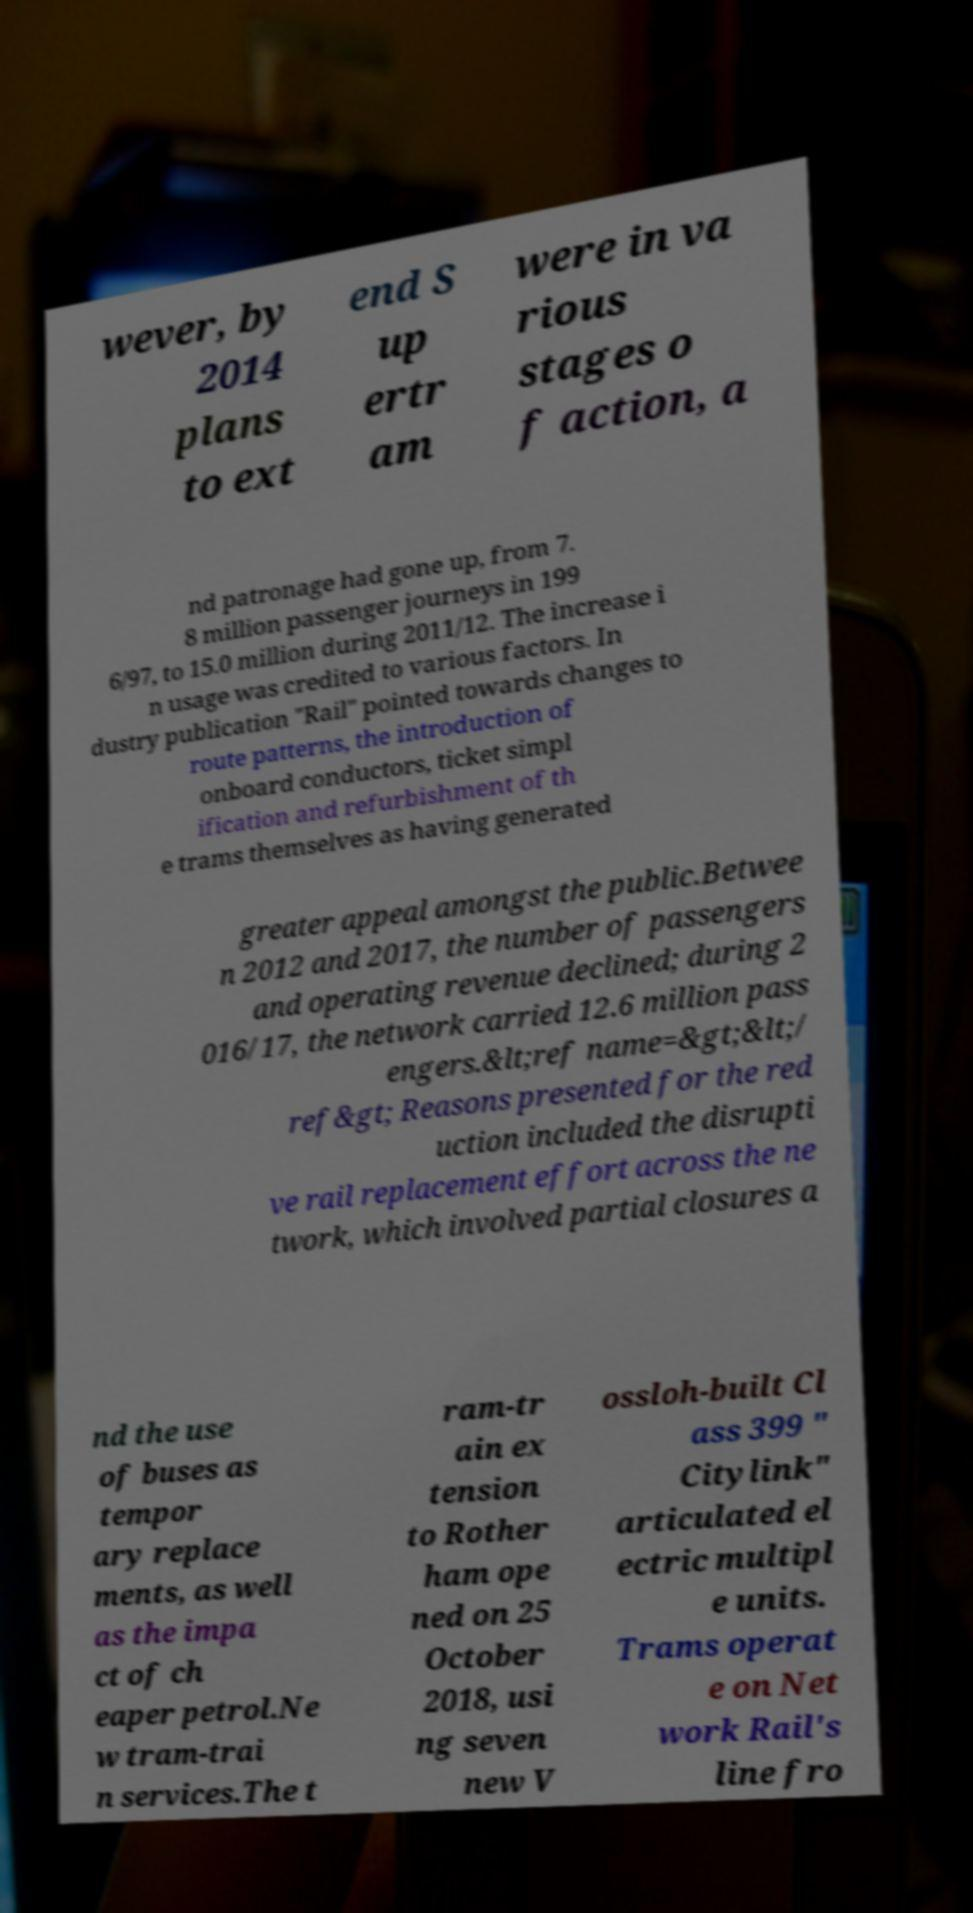There's text embedded in this image that I need extracted. Can you transcribe it verbatim? wever, by 2014 plans to ext end S up ertr am were in va rious stages o f action, a nd patronage had gone up, from 7. 8 million passenger journeys in 199 6/97, to 15.0 million during 2011/12. The increase i n usage was credited to various factors. In dustry publication "Rail" pointed towards changes to route patterns, the introduction of onboard conductors, ticket simpl ification and refurbishment of th e trams themselves as having generated greater appeal amongst the public.Betwee n 2012 and 2017, the number of passengers and operating revenue declined; during 2 016/17, the network carried 12.6 million pass engers.&lt;ref name=&gt;&lt;/ ref&gt; Reasons presented for the red uction included the disrupti ve rail replacement effort across the ne twork, which involved partial closures a nd the use of buses as tempor ary replace ments, as well as the impa ct of ch eaper petrol.Ne w tram-trai n services.The t ram-tr ain ex tension to Rother ham ope ned on 25 October 2018, usi ng seven new V ossloh-built Cl ass 399 " Citylink" articulated el ectric multipl e units. Trams operat e on Net work Rail's line fro 